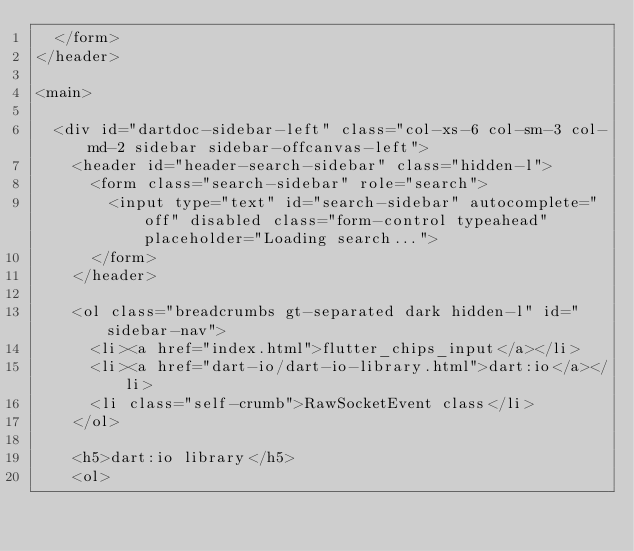<code> <loc_0><loc_0><loc_500><loc_500><_HTML_>  </form>
</header>

<main>

  <div id="dartdoc-sidebar-left" class="col-xs-6 col-sm-3 col-md-2 sidebar sidebar-offcanvas-left">
    <header id="header-search-sidebar" class="hidden-l">
      <form class="search-sidebar" role="search">
        <input type="text" id="search-sidebar" autocomplete="off" disabled class="form-control typeahead" placeholder="Loading search...">
      </form>
    </header>
    
    <ol class="breadcrumbs gt-separated dark hidden-l" id="sidebar-nav">
      <li><a href="index.html">flutter_chips_input</a></li>
      <li><a href="dart-io/dart-io-library.html">dart:io</a></li>
      <li class="self-crumb">RawSocketEvent class</li>
    </ol>
    
    <h5>dart:io library</h5>
    <ol></code> 